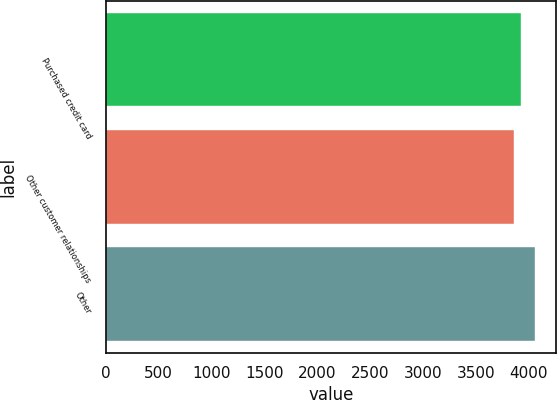Convert chart to OTSL. <chart><loc_0><loc_0><loc_500><loc_500><bar_chart><fcel>Purchased credit card<fcel>Other customer relationships<fcel>Other<nl><fcel>3930<fcel>3863<fcel>4058<nl></chart> 